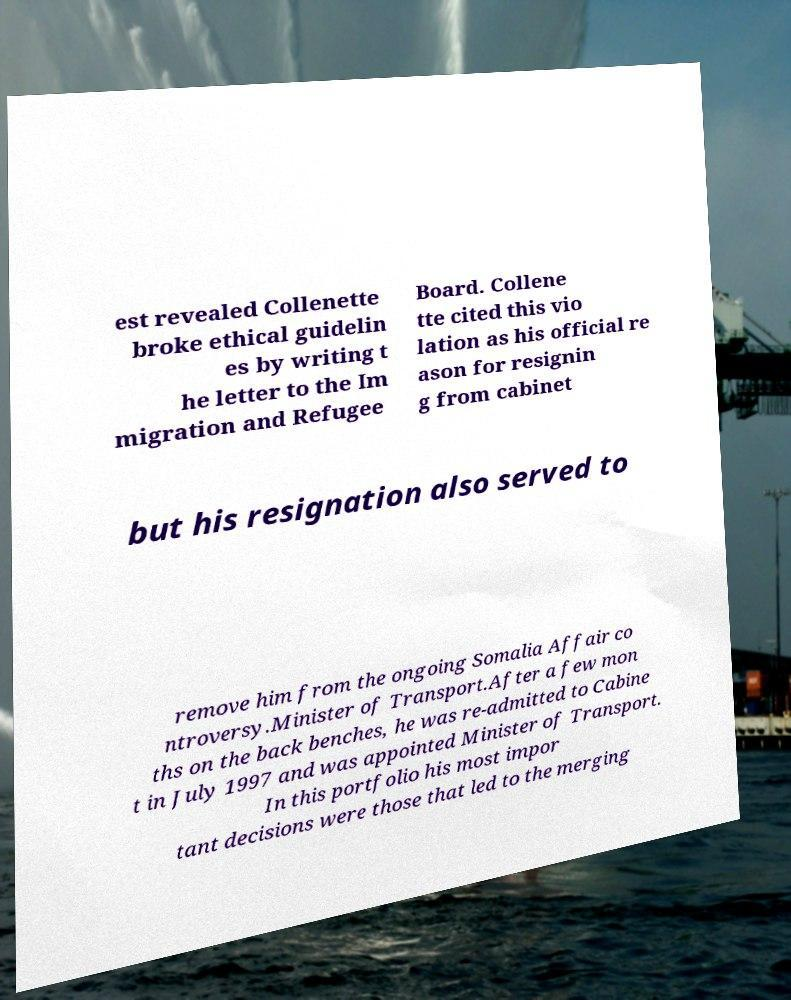I need the written content from this picture converted into text. Can you do that? est revealed Collenette broke ethical guidelin es by writing t he letter to the Im migration and Refugee Board. Collene tte cited this vio lation as his official re ason for resignin g from cabinet but his resignation also served to remove him from the ongoing Somalia Affair co ntroversy.Minister of Transport.After a few mon ths on the back benches, he was re-admitted to Cabine t in July 1997 and was appointed Minister of Transport. In this portfolio his most impor tant decisions were those that led to the merging 